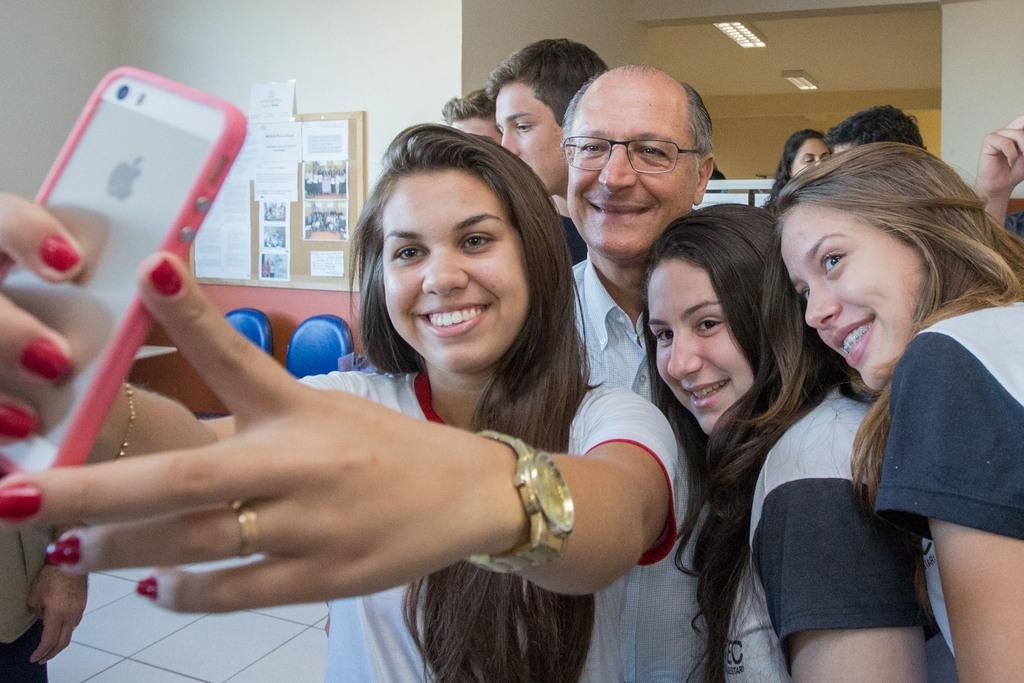What is the person in the image doing? The person in the image is taking a selfie. How many people are visible in the background of the image? There are many people behind the person taking the selfie. What can be seen on the left side of the image? There is a notice board on the left side of the image. What is attached to the notice board? Many papers are stuck to the notice board. What type of lipstick is the person wearing in the image? There is no information about the person's lipstick in the image. How many sticks are visible in the image? There is no mention of sticks in the image. 